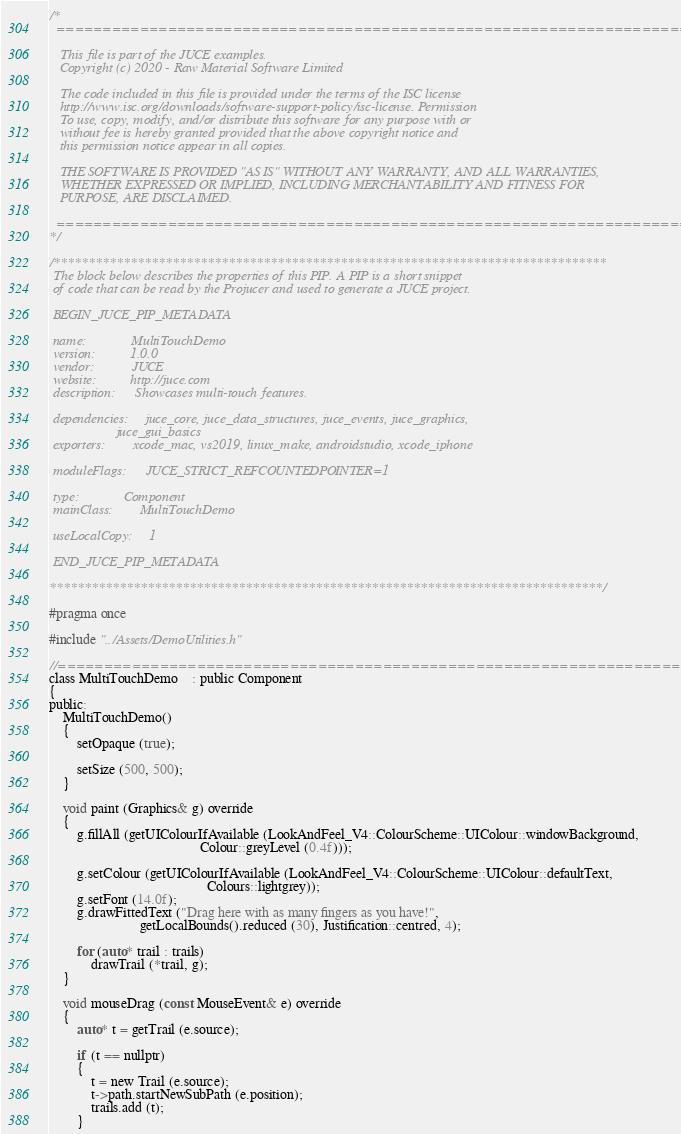<code> <loc_0><loc_0><loc_500><loc_500><_C_>/*
  ==============================================================================

   This file is part of the JUCE examples.
   Copyright (c) 2020 - Raw Material Software Limited

   The code included in this file is provided under the terms of the ISC license
   http://www.isc.org/downloads/software-support-policy/isc-license. Permission
   To use, copy, modify, and/or distribute this software for any purpose with or
   without fee is hereby granted provided that the above copyright notice and
   this permission notice appear in all copies.

   THE SOFTWARE IS PROVIDED "AS IS" WITHOUT ANY WARRANTY, AND ALL WARRANTIES,
   WHETHER EXPRESSED OR IMPLIED, INCLUDING MERCHANTABILITY AND FITNESS FOR
   PURPOSE, ARE DISCLAIMED.

  ==============================================================================
*/

/*******************************************************************************
 The block below describes the properties of this PIP. A PIP is a short snippet
 of code that can be read by the Projucer and used to generate a JUCE project.

 BEGIN_JUCE_PIP_METADATA

 name:             MultiTouchDemo
 version:          1.0.0
 vendor:           JUCE
 website:          http://juce.com
 description:      Showcases multi-touch features.

 dependencies:     juce_core, juce_data_structures, juce_events, juce_graphics,
                   juce_gui_basics
 exporters:        xcode_mac, vs2019, linux_make, androidstudio, xcode_iphone

 moduleFlags:      JUCE_STRICT_REFCOUNTEDPOINTER=1

 type:             Component
 mainClass:        MultiTouchDemo

 useLocalCopy:     1

 END_JUCE_PIP_METADATA

*******************************************************************************/

#pragma once

#include "../Assets/DemoUtilities.h"

//==============================================================================
class MultiTouchDemo    : public Component
{
public:
    MultiTouchDemo()
    {
        setOpaque (true);

        setSize (500, 500);
    }

    void paint (Graphics& g) override
    {
        g.fillAll (getUIColourIfAvailable (LookAndFeel_V4::ColourScheme::UIColour::windowBackground,
                                           Colour::greyLevel (0.4f)));

        g.setColour (getUIColourIfAvailable (LookAndFeel_V4::ColourScheme::UIColour::defaultText,
                                             Colours::lightgrey));
        g.setFont (14.0f);
        g.drawFittedText ("Drag here with as many fingers as you have!",
                          getLocalBounds().reduced (30), Justification::centred, 4);

        for (auto* trail : trails)
            drawTrail (*trail, g);
    }

    void mouseDrag (const MouseEvent& e) override
    {
        auto* t = getTrail (e.source);

        if (t == nullptr)
        {
            t = new Trail (e.source);
            t->path.startNewSubPath (e.position);
            trails.add (t);
        }
</code> 